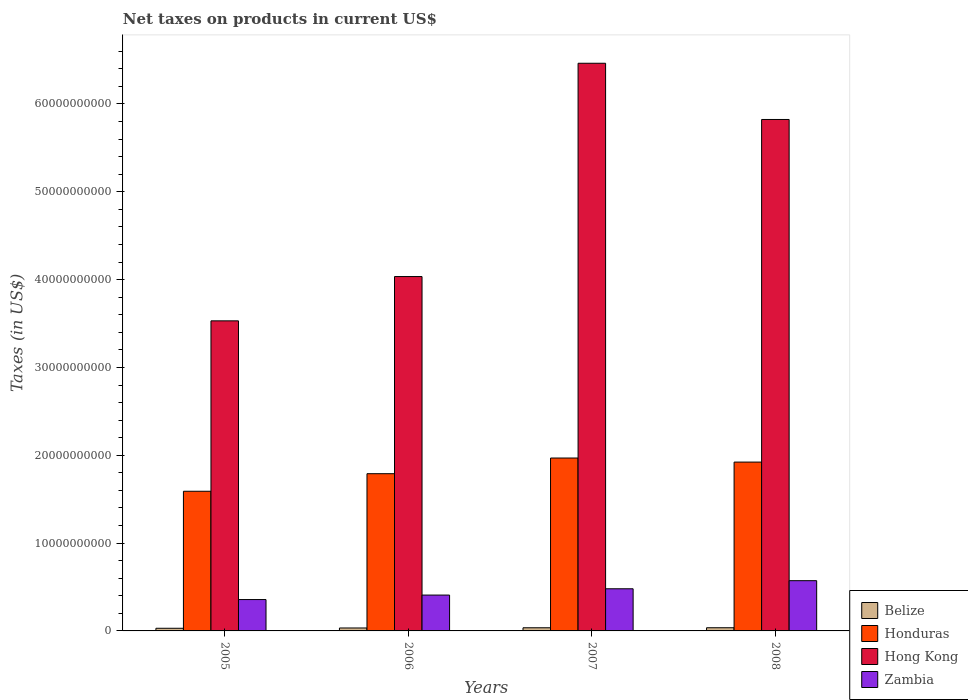How many different coloured bars are there?
Your answer should be very brief. 4. What is the net taxes on products in Honduras in 2005?
Give a very brief answer. 1.59e+1. Across all years, what is the maximum net taxes on products in Zambia?
Offer a very short reply. 5.72e+09. Across all years, what is the minimum net taxes on products in Zambia?
Ensure brevity in your answer.  3.57e+09. In which year was the net taxes on products in Honduras minimum?
Keep it short and to the point. 2005. What is the total net taxes on products in Zambia in the graph?
Make the answer very short. 1.82e+1. What is the difference between the net taxes on products in Honduras in 2005 and that in 2007?
Offer a very short reply. -3.78e+09. What is the difference between the net taxes on products in Hong Kong in 2007 and the net taxes on products in Honduras in 2005?
Give a very brief answer. 4.87e+1. What is the average net taxes on products in Honduras per year?
Make the answer very short. 1.82e+1. In the year 2005, what is the difference between the net taxes on products in Belize and net taxes on products in Honduras?
Offer a terse response. -1.56e+1. In how many years, is the net taxes on products in Hong Kong greater than 56000000000 US$?
Your answer should be very brief. 2. What is the ratio of the net taxes on products in Honduras in 2006 to that in 2007?
Give a very brief answer. 0.91. Is the net taxes on products in Belize in 2005 less than that in 2006?
Provide a succinct answer. Yes. What is the difference between the highest and the second highest net taxes on products in Belize?
Make the answer very short. 3.65e+06. What is the difference between the highest and the lowest net taxes on products in Belize?
Provide a succinct answer. 6.12e+07. In how many years, is the net taxes on products in Hong Kong greater than the average net taxes on products in Hong Kong taken over all years?
Your answer should be compact. 2. What does the 4th bar from the left in 2005 represents?
Your answer should be very brief. Zambia. What does the 3rd bar from the right in 2005 represents?
Your answer should be compact. Honduras. Is it the case that in every year, the sum of the net taxes on products in Honduras and net taxes on products in Zambia is greater than the net taxes on products in Hong Kong?
Provide a succinct answer. No. Are all the bars in the graph horizontal?
Offer a very short reply. No. Does the graph contain any zero values?
Provide a short and direct response. No. What is the title of the graph?
Your response must be concise. Net taxes on products in current US$. What is the label or title of the Y-axis?
Your answer should be very brief. Taxes (in US$). What is the Taxes (in US$) of Belize in 2005?
Make the answer very short. 3.01e+08. What is the Taxes (in US$) in Honduras in 2005?
Your answer should be very brief. 1.59e+1. What is the Taxes (in US$) of Hong Kong in 2005?
Offer a very short reply. 3.53e+1. What is the Taxes (in US$) in Zambia in 2005?
Give a very brief answer. 3.57e+09. What is the Taxes (in US$) in Belize in 2006?
Ensure brevity in your answer.  3.34e+08. What is the Taxes (in US$) of Honduras in 2006?
Provide a succinct answer. 1.79e+1. What is the Taxes (in US$) in Hong Kong in 2006?
Offer a terse response. 4.03e+1. What is the Taxes (in US$) of Zambia in 2006?
Provide a succinct answer. 4.08e+09. What is the Taxes (in US$) in Belize in 2007?
Give a very brief answer. 3.59e+08. What is the Taxes (in US$) of Honduras in 2007?
Give a very brief answer. 1.97e+1. What is the Taxes (in US$) in Hong Kong in 2007?
Provide a short and direct response. 6.46e+1. What is the Taxes (in US$) of Zambia in 2007?
Provide a short and direct response. 4.80e+09. What is the Taxes (in US$) of Belize in 2008?
Make the answer very short. 3.62e+08. What is the Taxes (in US$) in Honduras in 2008?
Give a very brief answer. 1.92e+1. What is the Taxes (in US$) in Hong Kong in 2008?
Your response must be concise. 5.82e+1. What is the Taxes (in US$) of Zambia in 2008?
Your answer should be very brief. 5.72e+09. Across all years, what is the maximum Taxes (in US$) of Belize?
Provide a succinct answer. 3.62e+08. Across all years, what is the maximum Taxes (in US$) in Honduras?
Offer a terse response. 1.97e+1. Across all years, what is the maximum Taxes (in US$) of Hong Kong?
Provide a succinct answer. 6.46e+1. Across all years, what is the maximum Taxes (in US$) of Zambia?
Offer a terse response. 5.72e+09. Across all years, what is the minimum Taxes (in US$) of Belize?
Offer a terse response. 3.01e+08. Across all years, what is the minimum Taxes (in US$) in Honduras?
Your response must be concise. 1.59e+1. Across all years, what is the minimum Taxes (in US$) of Hong Kong?
Your answer should be compact. 3.53e+1. Across all years, what is the minimum Taxes (in US$) of Zambia?
Provide a succinct answer. 3.57e+09. What is the total Taxes (in US$) of Belize in the graph?
Your answer should be very brief. 1.36e+09. What is the total Taxes (in US$) in Honduras in the graph?
Your answer should be very brief. 7.27e+1. What is the total Taxes (in US$) in Hong Kong in the graph?
Offer a very short reply. 1.99e+11. What is the total Taxes (in US$) of Zambia in the graph?
Make the answer very short. 1.82e+1. What is the difference between the Taxes (in US$) in Belize in 2005 and that in 2006?
Make the answer very short. -3.32e+07. What is the difference between the Taxes (in US$) in Honduras in 2005 and that in 2006?
Offer a very short reply. -2.00e+09. What is the difference between the Taxes (in US$) of Hong Kong in 2005 and that in 2006?
Offer a very short reply. -5.04e+09. What is the difference between the Taxes (in US$) in Zambia in 2005 and that in 2006?
Your answer should be very brief. -5.11e+08. What is the difference between the Taxes (in US$) of Belize in 2005 and that in 2007?
Your response must be concise. -5.76e+07. What is the difference between the Taxes (in US$) of Honduras in 2005 and that in 2007?
Provide a short and direct response. -3.78e+09. What is the difference between the Taxes (in US$) of Hong Kong in 2005 and that in 2007?
Your answer should be very brief. -2.93e+1. What is the difference between the Taxes (in US$) of Zambia in 2005 and that in 2007?
Keep it short and to the point. -1.23e+09. What is the difference between the Taxes (in US$) in Belize in 2005 and that in 2008?
Offer a terse response. -6.12e+07. What is the difference between the Taxes (in US$) in Honduras in 2005 and that in 2008?
Give a very brief answer. -3.32e+09. What is the difference between the Taxes (in US$) in Hong Kong in 2005 and that in 2008?
Your answer should be very brief. -2.29e+1. What is the difference between the Taxes (in US$) of Zambia in 2005 and that in 2008?
Give a very brief answer. -2.15e+09. What is the difference between the Taxes (in US$) of Belize in 2006 and that in 2007?
Keep it short and to the point. -2.44e+07. What is the difference between the Taxes (in US$) of Honduras in 2006 and that in 2007?
Provide a short and direct response. -1.78e+09. What is the difference between the Taxes (in US$) of Hong Kong in 2006 and that in 2007?
Provide a succinct answer. -2.43e+1. What is the difference between the Taxes (in US$) of Zambia in 2006 and that in 2007?
Ensure brevity in your answer.  -7.17e+08. What is the difference between the Taxes (in US$) of Belize in 2006 and that in 2008?
Your answer should be very brief. -2.80e+07. What is the difference between the Taxes (in US$) of Honduras in 2006 and that in 2008?
Give a very brief answer. -1.32e+09. What is the difference between the Taxes (in US$) in Hong Kong in 2006 and that in 2008?
Your answer should be very brief. -1.79e+1. What is the difference between the Taxes (in US$) of Zambia in 2006 and that in 2008?
Keep it short and to the point. -1.64e+09. What is the difference between the Taxes (in US$) of Belize in 2007 and that in 2008?
Your response must be concise. -3.65e+06. What is the difference between the Taxes (in US$) in Honduras in 2007 and that in 2008?
Offer a terse response. 4.63e+08. What is the difference between the Taxes (in US$) of Hong Kong in 2007 and that in 2008?
Your answer should be compact. 6.40e+09. What is the difference between the Taxes (in US$) of Zambia in 2007 and that in 2008?
Give a very brief answer. -9.20e+08. What is the difference between the Taxes (in US$) in Belize in 2005 and the Taxes (in US$) in Honduras in 2006?
Your response must be concise. -1.76e+1. What is the difference between the Taxes (in US$) in Belize in 2005 and the Taxes (in US$) in Hong Kong in 2006?
Your answer should be very brief. -4.00e+1. What is the difference between the Taxes (in US$) of Belize in 2005 and the Taxes (in US$) of Zambia in 2006?
Keep it short and to the point. -3.78e+09. What is the difference between the Taxes (in US$) in Honduras in 2005 and the Taxes (in US$) in Hong Kong in 2006?
Give a very brief answer. -2.44e+1. What is the difference between the Taxes (in US$) in Honduras in 2005 and the Taxes (in US$) in Zambia in 2006?
Your response must be concise. 1.18e+1. What is the difference between the Taxes (in US$) in Hong Kong in 2005 and the Taxes (in US$) in Zambia in 2006?
Ensure brevity in your answer.  3.12e+1. What is the difference between the Taxes (in US$) of Belize in 2005 and the Taxes (in US$) of Honduras in 2007?
Give a very brief answer. -1.94e+1. What is the difference between the Taxes (in US$) of Belize in 2005 and the Taxes (in US$) of Hong Kong in 2007?
Your response must be concise. -6.43e+1. What is the difference between the Taxes (in US$) of Belize in 2005 and the Taxes (in US$) of Zambia in 2007?
Make the answer very short. -4.50e+09. What is the difference between the Taxes (in US$) of Honduras in 2005 and the Taxes (in US$) of Hong Kong in 2007?
Make the answer very short. -4.87e+1. What is the difference between the Taxes (in US$) of Honduras in 2005 and the Taxes (in US$) of Zambia in 2007?
Your answer should be very brief. 1.11e+1. What is the difference between the Taxes (in US$) of Hong Kong in 2005 and the Taxes (in US$) of Zambia in 2007?
Your response must be concise. 3.05e+1. What is the difference between the Taxes (in US$) in Belize in 2005 and the Taxes (in US$) in Honduras in 2008?
Your answer should be compact. -1.89e+1. What is the difference between the Taxes (in US$) of Belize in 2005 and the Taxes (in US$) of Hong Kong in 2008?
Offer a terse response. -5.79e+1. What is the difference between the Taxes (in US$) of Belize in 2005 and the Taxes (in US$) of Zambia in 2008?
Give a very brief answer. -5.42e+09. What is the difference between the Taxes (in US$) of Honduras in 2005 and the Taxes (in US$) of Hong Kong in 2008?
Your response must be concise. -4.23e+1. What is the difference between the Taxes (in US$) in Honduras in 2005 and the Taxes (in US$) in Zambia in 2008?
Keep it short and to the point. 1.02e+1. What is the difference between the Taxes (in US$) in Hong Kong in 2005 and the Taxes (in US$) in Zambia in 2008?
Provide a succinct answer. 2.96e+1. What is the difference between the Taxes (in US$) in Belize in 2006 and the Taxes (in US$) in Honduras in 2007?
Give a very brief answer. -1.94e+1. What is the difference between the Taxes (in US$) of Belize in 2006 and the Taxes (in US$) of Hong Kong in 2007?
Your answer should be very brief. -6.43e+1. What is the difference between the Taxes (in US$) of Belize in 2006 and the Taxes (in US$) of Zambia in 2007?
Your response must be concise. -4.46e+09. What is the difference between the Taxes (in US$) in Honduras in 2006 and the Taxes (in US$) in Hong Kong in 2007?
Offer a terse response. -4.67e+1. What is the difference between the Taxes (in US$) in Honduras in 2006 and the Taxes (in US$) in Zambia in 2007?
Provide a short and direct response. 1.31e+1. What is the difference between the Taxes (in US$) in Hong Kong in 2006 and the Taxes (in US$) in Zambia in 2007?
Ensure brevity in your answer.  3.55e+1. What is the difference between the Taxes (in US$) of Belize in 2006 and the Taxes (in US$) of Honduras in 2008?
Provide a succinct answer. -1.89e+1. What is the difference between the Taxes (in US$) in Belize in 2006 and the Taxes (in US$) in Hong Kong in 2008?
Ensure brevity in your answer.  -5.79e+1. What is the difference between the Taxes (in US$) in Belize in 2006 and the Taxes (in US$) in Zambia in 2008?
Ensure brevity in your answer.  -5.39e+09. What is the difference between the Taxes (in US$) in Honduras in 2006 and the Taxes (in US$) in Hong Kong in 2008?
Provide a succinct answer. -4.03e+1. What is the difference between the Taxes (in US$) in Honduras in 2006 and the Taxes (in US$) in Zambia in 2008?
Ensure brevity in your answer.  1.22e+1. What is the difference between the Taxes (in US$) of Hong Kong in 2006 and the Taxes (in US$) of Zambia in 2008?
Your response must be concise. 3.46e+1. What is the difference between the Taxes (in US$) in Belize in 2007 and the Taxes (in US$) in Honduras in 2008?
Your response must be concise. -1.89e+1. What is the difference between the Taxes (in US$) of Belize in 2007 and the Taxes (in US$) of Hong Kong in 2008?
Keep it short and to the point. -5.79e+1. What is the difference between the Taxes (in US$) in Belize in 2007 and the Taxes (in US$) in Zambia in 2008?
Your answer should be compact. -5.36e+09. What is the difference between the Taxes (in US$) of Honduras in 2007 and the Taxes (in US$) of Hong Kong in 2008?
Provide a succinct answer. -3.85e+1. What is the difference between the Taxes (in US$) in Honduras in 2007 and the Taxes (in US$) in Zambia in 2008?
Your answer should be compact. 1.40e+1. What is the difference between the Taxes (in US$) in Hong Kong in 2007 and the Taxes (in US$) in Zambia in 2008?
Your answer should be compact. 5.89e+1. What is the average Taxes (in US$) in Belize per year?
Provide a short and direct response. 3.39e+08. What is the average Taxes (in US$) of Honduras per year?
Offer a very short reply. 1.82e+1. What is the average Taxes (in US$) in Hong Kong per year?
Keep it short and to the point. 4.96e+1. What is the average Taxes (in US$) of Zambia per year?
Provide a short and direct response. 4.54e+09. In the year 2005, what is the difference between the Taxes (in US$) of Belize and Taxes (in US$) of Honduras?
Make the answer very short. -1.56e+1. In the year 2005, what is the difference between the Taxes (in US$) in Belize and Taxes (in US$) in Hong Kong?
Give a very brief answer. -3.50e+1. In the year 2005, what is the difference between the Taxes (in US$) in Belize and Taxes (in US$) in Zambia?
Give a very brief answer. -3.27e+09. In the year 2005, what is the difference between the Taxes (in US$) of Honduras and Taxes (in US$) of Hong Kong?
Keep it short and to the point. -1.94e+1. In the year 2005, what is the difference between the Taxes (in US$) in Honduras and Taxes (in US$) in Zambia?
Your answer should be compact. 1.23e+1. In the year 2005, what is the difference between the Taxes (in US$) of Hong Kong and Taxes (in US$) of Zambia?
Offer a very short reply. 3.17e+1. In the year 2006, what is the difference between the Taxes (in US$) of Belize and Taxes (in US$) of Honduras?
Keep it short and to the point. -1.76e+1. In the year 2006, what is the difference between the Taxes (in US$) in Belize and Taxes (in US$) in Hong Kong?
Provide a succinct answer. -4.00e+1. In the year 2006, what is the difference between the Taxes (in US$) in Belize and Taxes (in US$) in Zambia?
Give a very brief answer. -3.75e+09. In the year 2006, what is the difference between the Taxes (in US$) in Honduras and Taxes (in US$) in Hong Kong?
Your response must be concise. -2.24e+1. In the year 2006, what is the difference between the Taxes (in US$) in Honduras and Taxes (in US$) in Zambia?
Provide a succinct answer. 1.38e+1. In the year 2006, what is the difference between the Taxes (in US$) of Hong Kong and Taxes (in US$) of Zambia?
Keep it short and to the point. 3.63e+1. In the year 2007, what is the difference between the Taxes (in US$) in Belize and Taxes (in US$) in Honduras?
Your response must be concise. -1.93e+1. In the year 2007, what is the difference between the Taxes (in US$) of Belize and Taxes (in US$) of Hong Kong?
Offer a terse response. -6.43e+1. In the year 2007, what is the difference between the Taxes (in US$) of Belize and Taxes (in US$) of Zambia?
Keep it short and to the point. -4.44e+09. In the year 2007, what is the difference between the Taxes (in US$) of Honduras and Taxes (in US$) of Hong Kong?
Keep it short and to the point. -4.49e+1. In the year 2007, what is the difference between the Taxes (in US$) of Honduras and Taxes (in US$) of Zambia?
Keep it short and to the point. 1.49e+1. In the year 2007, what is the difference between the Taxes (in US$) of Hong Kong and Taxes (in US$) of Zambia?
Your answer should be compact. 5.98e+1. In the year 2008, what is the difference between the Taxes (in US$) in Belize and Taxes (in US$) in Honduras?
Your answer should be compact. -1.89e+1. In the year 2008, what is the difference between the Taxes (in US$) of Belize and Taxes (in US$) of Hong Kong?
Your answer should be very brief. -5.79e+1. In the year 2008, what is the difference between the Taxes (in US$) in Belize and Taxes (in US$) in Zambia?
Offer a terse response. -5.36e+09. In the year 2008, what is the difference between the Taxes (in US$) in Honduras and Taxes (in US$) in Hong Kong?
Your answer should be very brief. -3.90e+1. In the year 2008, what is the difference between the Taxes (in US$) of Honduras and Taxes (in US$) of Zambia?
Keep it short and to the point. 1.35e+1. In the year 2008, what is the difference between the Taxes (in US$) of Hong Kong and Taxes (in US$) of Zambia?
Ensure brevity in your answer.  5.25e+1. What is the ratio of the Taxes (in US$) in Belize in 2005 to that in 2006?
Provide a short and direct response. 0.9. What is the ratio of the Taxes (in US$) of Honduras in 2005 to that in 2006?
Provide a succinct answer. 0.89. What is the ratio of the Taxes (in US$) of Zambia in 2005 to that in 2006?
Make the answer very short. 0.87. What is the ratio of the Taxes (in US$) of Belize in 2005 to that in 2007?
Provide a succinct answer. 0.84. What is the ratio of the Taxes (in US$) of Honduras in 2005 to that in 2007?
Your answer should be very brief. 0.81. What is the ratio of the Taxes (in US$) in Hong Kong in 2005 to that in 2007?
Your answer should be compact. 0.55. What is the ratio of the Taxes (in US$) in Zambia in 2005 to that in 2007?
Your answer should be very brief. 0.74. What is the ratio of the Taxes (in US$) of Belize in 2005 to that in 2008?
Make the answer very short. 0.83. What is the ratio of the Taxes (in US$) in Honduras in 2005 to that in 2008?
Your answer should be compact. 0.83. What is the ratio of the Taxes (in US$) in Hong Kong in 2005 to that in 2008?
Ensure brevity in your answer.  0.61. What is the ratio of the Taxes (in US$) of Zambia in 2005 to that in 2008?
Your response must be concise. 0.62. What is the ratio of the Taxes (in US$) of Belize in 2006 to that in 2007?
Offer a terse response. 0.93. What is the ratio of the Taxes (in US$) of Honduras in 2006 to that in 2007?
Offer a terse response. 0.91. What is the ratio of the Taxes (in US$) of Hong Kong in 2006 to that in 2007?
Ensure brevity in your answer.  0.62. What is the ratio of the Taxes (in US$) in Zambia in 2006 to that in 2007?
Give a very brief answer. 0.85. What is the ratio of the Taxes (in US$) of Belize in 2006 to that in 2008?
Ensure brevity in your answer.  0.92. What is the ratio of the Taxes (in US$) of Honduras in 2006 to that in 2008?
Your answer should be very brief. 0.93. What is the ratio of the Taxes (in US$) in Hong Kong in 2006 to that in 2008?
Make the answer very short. 0.69. What is the ratio of the Taxes (in US$) in Zambia in 2006 to that in 2008?
Your answer should be very brief. 0.71. What is the ratio of the Taxes (in US$) in Honduras in 2007 to that in 2008?
Your response must be concise. 1.02. What is the ratio of the Taxes (in US$) in Hong Kong in 2007 to that in 2008?
Provide a short and direct response. 1.11. What is the ratio of the Taxes (in US$) of Zambia in 2007 to that in 2008?
Make the answer very short. 0.84. What is the difference between the highest and the second highest Taxes (in US$) of Belize?
Offer a terse response. 3.65e+06. What is the difference between the highest and the second highest Taxes (in US$) of Honduras?
Give a very brief answer. 4.63e+08. What is the difference between the highest and the second highest Taxes (in US$) of Hong Kong?
Your answer should be very brief. 6.40e+09. What is the difference between the highest and the second highest Taxes (in US$) in Zambia?
Offer a very short reply. 9.20e+08. What is the difference between the highest and the lowest Taxes (in US$) in Belize?
Ensure brevity in your answer.  6.12e+07. What is the difference between the highest and the lowest Taxes (in US$) in Honduras?
Your answer should be very brief. 3.78e+09. What is the difference between the highest and the lowest Taxes (in US$) of Hong Kong?
Ensure brevity in your answer.  2.93e+1. What is the difference between the highest and the lowest Taxes (in US$) in Zambia?
Offer a terse response. 2.15e+09. 